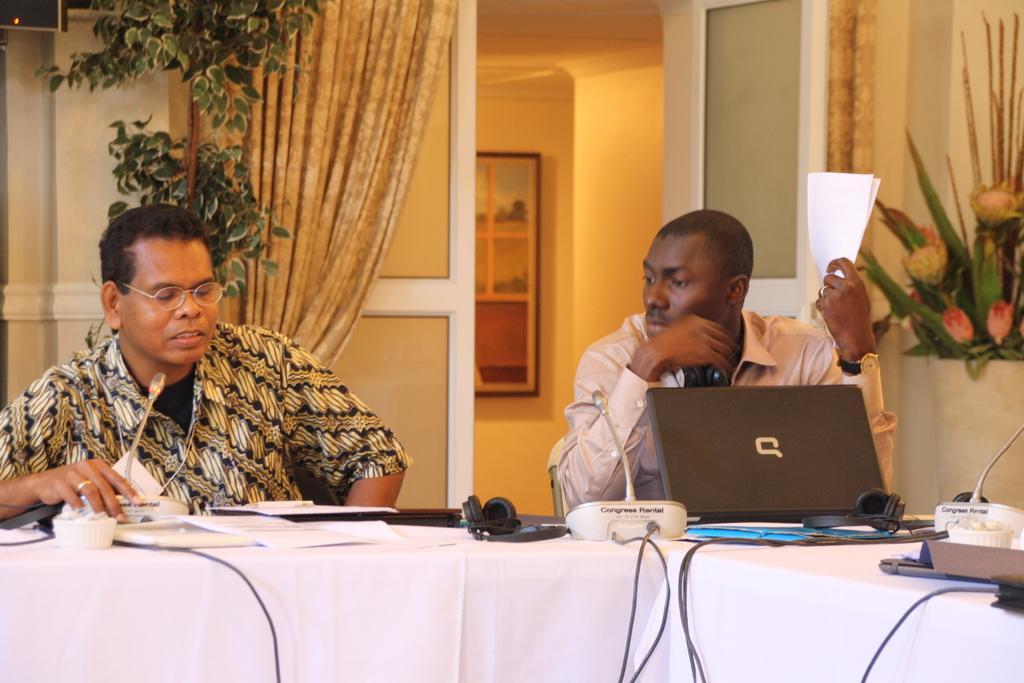Please provide a concise description of this image. These two persons are sitting on chair. In-front of them there is a table, on this table there is a headset, mic, cables, laptops, papers and cup. This person is looking left side and holding papers. This man wore spectacles and looking at this papers. At the background there is a curtain, plant and a picture on wall. 